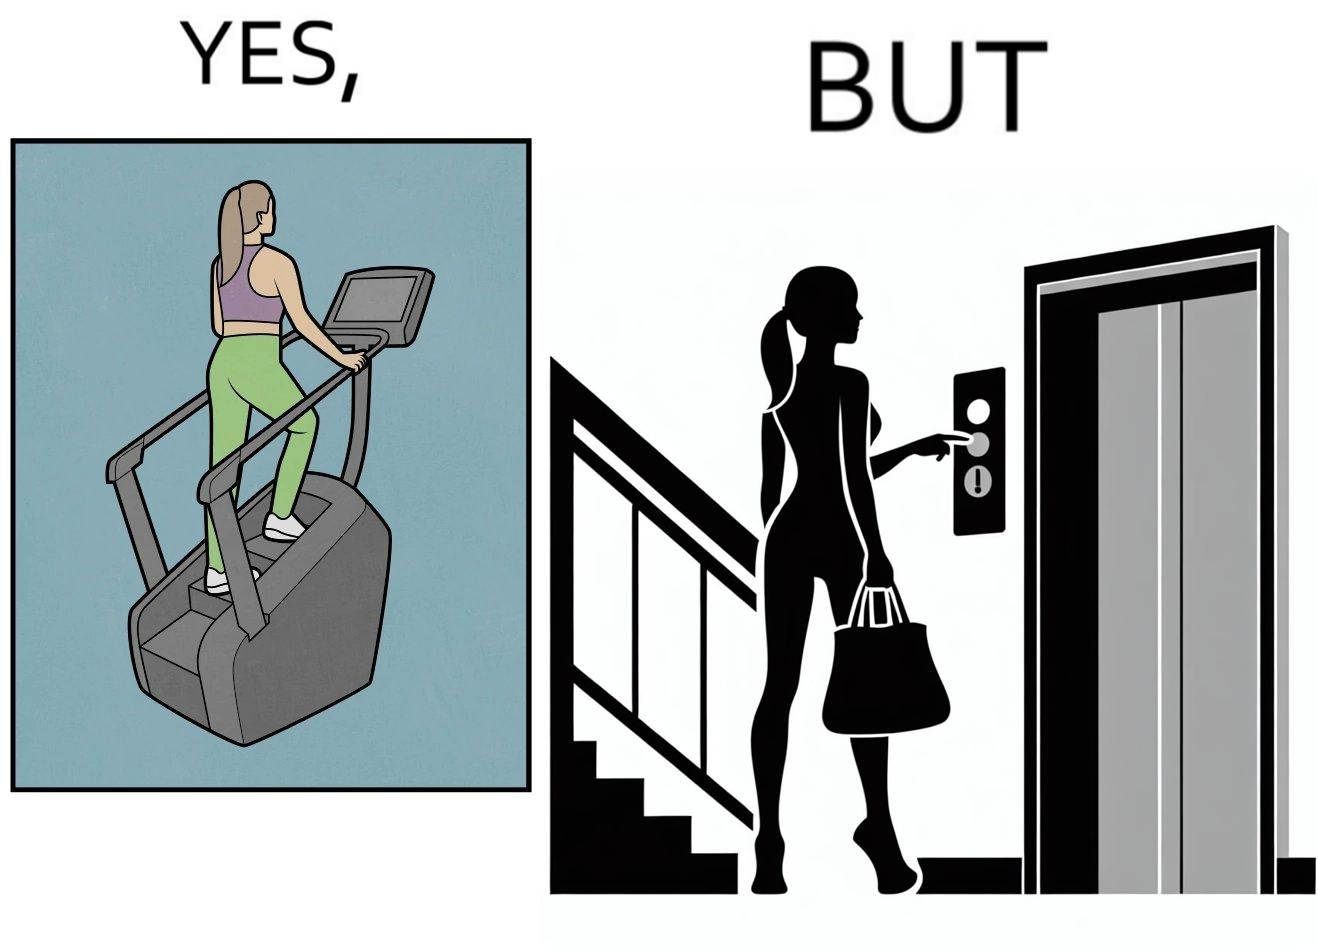What is shown in the left half versus the right half of this image? In the left part of the image: a woman is seen using the stair climber machine at some gym In the right part of the image: a woman calling for the lift to avoid climbing up the stairs for going to the gym 